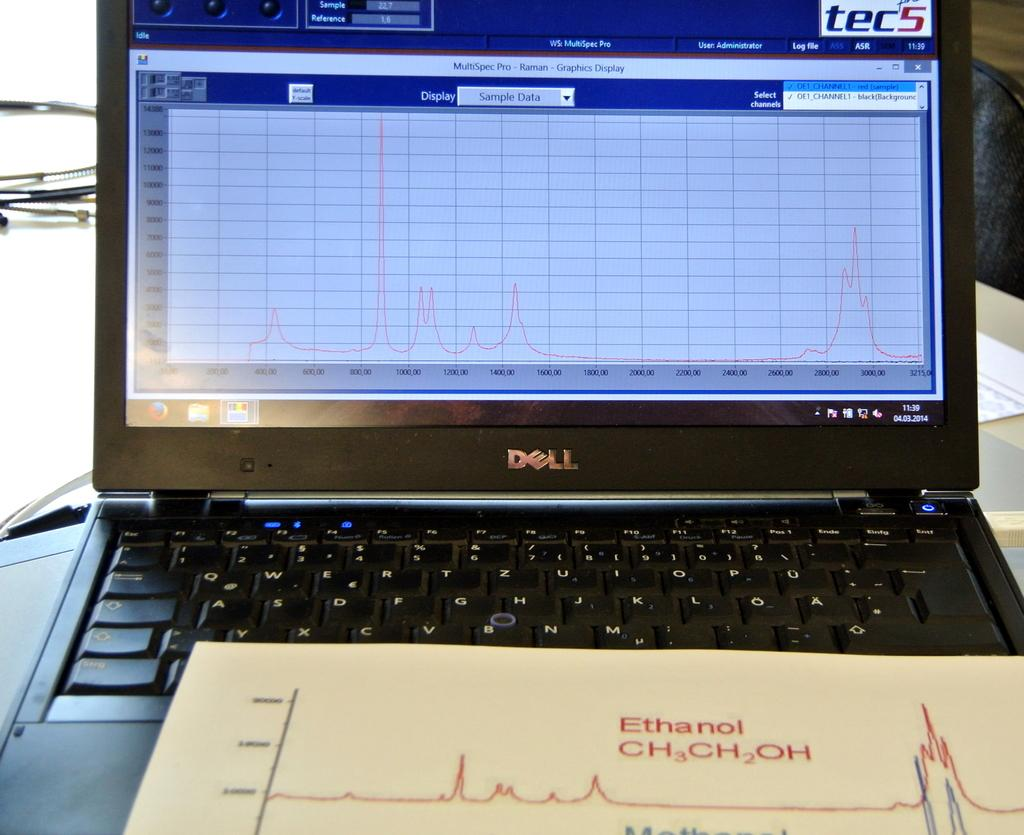What electronic device is visible in the image? There is a laptop in the image. Where is the laptop located? The laptop is on a table. What else can be seen at the bottom of the image? There is a paper at the bottom of the image. What is the annual income of the person using the laptop in the image? There is no information about the person using the laptop or their income in the image. 